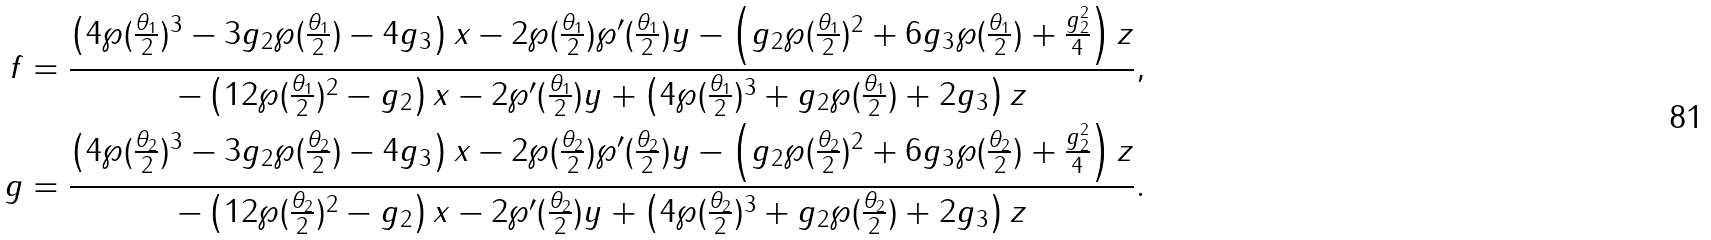<formula> <loc_0><loc_0><loc_500><loc_500>f & = \frac { \left ( 4 \wp ( \frac { \theta _ { 1 } } { 2 } ) ^ { 3 } - 3 g _ { 2 } \wp ( \frac { \theta _ { 1 } } { 2 } ) - 4 g _ { 3 } \right ) x - 2 \wp ( \frac { \theta _ { 1 } } { 2 } ) \wp ^ { \prime } ( \frac { \theta _ { 1 } } { 2 } ) y - \left ( g _ { 2 } \wp ( \frac { \theta _ { 1 } } { 2 } ) ^ { 2 } + 6 g _ { 3 } \wp ( \frac { \theta _ { 1 } } { 2 } ) + \frac { g _ { 2 } ^ { 2 } } { 4 } \right ) z } { - \left ( 1 2 \wp ( \frac { \theta _ { 1 } } { 2 } ) ^ { 2 } - g _ { 2 } \right ) x - 2 \wp ^ { \prime } ( \frac { \theta _ { 1 } } { 2 } ) y + \left ( 4 \wp ( \frac { \theta _ { 1 } } { 2 } ) ^ { 3 } + g _ { 2 } \wp ( \frac { \theta _ { 1 } } { 2 } ) + 2 g _ { 3 } \right ) z } , \\ g & = \frac { \left ( 4 \wp ( \frac { \theta _ { 2 } } { 2 } ) ^ { 3 } - 3 g _ { 2 } \wp ( \frac { \theta _ { 2 } } { 2 } ) - 4 g _ { 3 } \right ) x - 2 \wp ( \frac { \theta _ { 2 } } { 2 } ) \wp ^ { \prime } ( \frac { \theta _ { 2 } } { 2 } ) y - \left ( g _ { 2 } \wp ( \frac { \theta _ { 2 } } { 2 } ) ^ { 2 } + 6 g _ { 3 } \wp ( \frac { \theta _ { 2 } } { 2 } ) + \frac { g _ { 2 } ^ { 2 } } { 4 } \right ) z } { - \left ( 1 2 \wp ( \frac { \theta _ { 2 } } { 2 } ) ^ { 2 } - g _ { 2 } \right ) x - 2 \wp ^ { \prime } ( \frac { \theta _ { 2 } } { 2 } ) y + \left ( 4 \wp ( \frac { \theta _ { 2 } } { 2 } ) ^ { 3 } + g _ { 2 } \wp ( \frac { \theta _ { 2 } } { 2 } ) + 2 g _ { 3 } \right ) z } .</formula> 